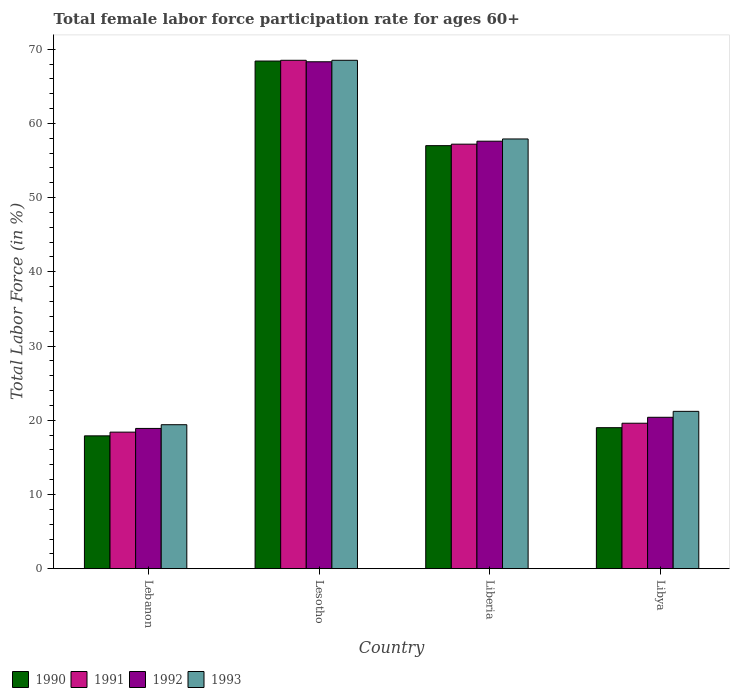How many different coloured bars are there?
Give a very brief answer. 4. How many bars are there on the 3rd tick from the left?
Make the answer very short. 4. How many bars are there on the 3rd tick from the right?
Make the answer very short. 4. What is the label of the 1st group of bars from the left?
Your response must be concise. Lebanon. What is the female labor force participation rate in 1990 in Libya?
Your response must be concise. 19. Across all countries, what is the maximum female labor force participation rate in 1993?
Provide a succinct answer. 68.5. Across all countries, what is the minimum female labor force participation rate in 1991?
Offer a very short reply. 18.4. In which country was the female labor force participation rate in 1990 maximum?
Your answer should be very brief. Lesotho. In which country was the female labor force participation rate in 1990 minimum?
Offer a terse response. Lebanon. What is the total female labor force participation rate in 1992 in the graph?
Provide a short and direct response. 165.2. What is the difference between the female labor force participation rate in 1992 in Lebanon and that in Lesotho?
Your answer should be very brief. -49.4. What is the difference between the female labor force participation rate in 1992 in Libya and the female labor force participation rate in 1993 in Liberia?
Your response must be concise. -37.5. What is the average female labor force participation rate in 1990 per country?
Your response must be concise. 40.58. What is the difference between the female labor force participation rate of/in 1990 and female labor force participation rate of/in 1992 in Libya?
Provide a succinct answer. -1.4. What is the ratio of the female labor force participation rate in 1990 in Lebanon to that in Libya?
Your answer should be very brief. 0.94. Is the difference between the female labor force participation rate in 1990 in Lebanon and Lesotho greater than the difference between the female labor force participation rate in 1992 in Lebanon and Lesotho?
Give a very brief answer. No. What is the difference between the highest and the second highest female labor force participation rate in 1991?
Provide a succinct answer. 37.6. What is the difference between the highest and the lowest female labor force participation rate in 1991?
Your response must be concise. 50.1. Is the sum of the female labor force participation rate in 1990 in Lebanon and Liberia greater than the maximum female labor force participation rate in 1993 across all countries?
Ensure brevity in your answer.  Yes. Is it the case that in every country, the sum of the female labor force participation rate in 1990 and female labor force participation rate in 1992 is greater than the sum of female labor force participation rate in 1991 and female labor force participation rate in 1993?
Provide a short and direct response. No. What does the 2nd bar from the right in Libya represents?
Offer a terse response. 1992. Are all the bars in the graph horizontal?
Ensure brevity in your answer.  No. Where does the legend appear in the graph?
Offer a terse response. Bottom left. What is the title of the graph?
Your answer should be very brief. Total female labor force participation rate for ages 60+. Does "2010" appear as one of the legend labels in the graph?
Your answer should be very brief. No. What is the Total Labor Force (in %) in 1990 in Lebanon?
Give a very brief answer. 17.9. What is the Total Labor Force (in %) of 1991 in Lebanon?
Offer a terse response. 18.4. What is the Total Labor Force (in %) in 1992 in Lebanon?
Your response must be concise. 18.9. What is the Total Labor Force (in %) in 1993 in Lebanon?
Offer a very short reply. 19.4. What is the Total Labor Force (in %) in 1990 in Lesotho?
Keep it short and to the point. 68.4. What is the Total Labor Force (in %) in 1991 in Lesotho?
Your answer should be compact. 68.5. What is the Total Labor Force (in %) in 1992 in Lesotho?
Your answer should be very brief. 68.3. What is the Total Labor Force (in %) of 1993 in Lesotho?
Give a very brief answer. 68.5. What is the Total Labor Force (in %) in 1990 in Liberia?
Provide a short and direct response. 57. What is the Total Labor Force (in %) in 1991 in Liberia?
Keep it short and to the point. 57.2. What is the Total Labor Force (in %) in 1992 in Liberia?
Keep it short and to the point. 57.6. What is the Total Labor Force (in %) of 1993 in Liberia?
Keep it short and to the point. 57.9. What is the Total Labor Force (in %) of 1990 in Libya?
Your response must be concise. 19. What is the Total Labor Force (in %) in 1991 in Libya?
Make the answer very short. 19.6. What is the Total Labor Force (in %) in 1992 in Libya?
Offer a terse response. 20.4. What is the Total Labor Force (in %) of 1993 in Libya?
Your answer should be compact. 21.2. Across all countries, what is the maximum Total Labor Force (in %) in 1990?
Ensure brevity in your answer.  68.4. Across all countries, what is the maximum Total Labor Force (in %) in 1991?
Offer a terse response. 68.5. Across all countries, what is the maximum Total Labor Force (in %) of 1992?
Your response must be concise. 68.3. Across all countries, what is the maximum Total Labor Force (in %) of 1993?
Keep it short and to the point. 68.5. Across all countries, what is the minimum Total Labor Force (in %) of 1990?
Give a very brief answer. 17.9. Across all countries, what is the minimum Total Labor Force (in %) of 1991?
Provide a succinct answer. 18.4. Across all countries, what is the minimum Total Labor Force (in %) of 1992?
Provide a short and direct response. 18.9. Across all countries, what is the minimum Total Labor Force (in %) in 1993?
Ensure brevity in your answer.  19.4. What is the total Total Labor Force (in %) of 1990 in the graph?
Your answer should be very brief. 162.3. What is the total Total Labor Force (in %) of 1991 in the graph?
Your answer should be compact. 163.7. What is the total Total Labor Force (in %) in 1992 in the graph?
Your answer should be compact. 165.2. What is the total Total Labor Force (in %) of 1993 in the graph?
Your answer should be very brief. 167. What is the difference between the Total Labor Force (in %) of 1990 in Lebanon and that in Lesotho?
Give a very brief answer. -50.5. What is the difference between the Total Labor Force (in %) in 1991 in Lebanon and that in Lesotho?
Offer a very short reply. -50.1. What is the difference between the Total Labor Force (in %) in 1992 in Lebanon and that in Lesotho?
Provide a succinct answer. -49.4. What is the difference between the Total Labor Force (in %) in 1993 in Lebanon and that in Lesotho?
Provide a succinct answer. -49.1. What is the difference between the Total Labor Force (in %) in 1990 in Lebanon and that in Liberia?
Your answer should be very brief. -39.1. What is the difference between the Total Labor Force (in %) of 1991 in Lebanon and that in Liberia?
Make the answer very short. -38.8. What is the difference between the Total Labor Force (in %) of 1992 in Lebanon and that in Liberia?
Keep it short and to the point. -38.7. What is the difference between the Total Labor Force (in %) in 1993 in Lebanon and that in Liberia?
Make the answer very short. -38.5. What is the difference between the Total Labor Force (in %) in 1992 in Lebanon and that in Libya?
Provide a succinct answer. -1.5. What is the difference between the Total Labor Force (in %) of 1993 in Lebanon and that in Libya?
Your response must be concise. -1.8. What is the difference between the Total Labor Force (in %) in 1991 in Lesotho and that in Liberia?
Provide a succinct answer. 11.3. What is the difference between the Total Labor Force (in %) in 1992 in Lesotho and that in Liberia?
Keep it short and to the point. 10.7. What is the difference between the Total Labor Force (in %) of 1990 in Lesotho and that in Libya?
Offer a very short reply. 49.4. What is the difference between the Total Labor Force (in %) of 1991 in Lesotho and that in Libya?
Make the answer very short. 48.9. What is the difference between the Total Labor Force (in %) of 1992 in Lesotho and that in Libya?
Your response must be concise. 47.9. What is the difference between the Total Labor Force (in %) in 1993 in Lesotho and that in Libya?
Offer a terse response. 47.3. What is the difference between the Total Labor Force (in %) of 1990 in Liberia and that in Libya?
Your response must be concise. 38. What is the difference between the Total Labor Force (in %) in 1991 in Liberia and that in Libya?
Make the answer very short. 37.6. What is the difference between the Total Labor Force (in %) of 1992 in Liberia and that in Libya?
Ensure brevity in your answer.  37.2. What is the difference between the Total Labor Force (in %) in 1993 in Liberia and that in Libya?
Your answer should be compact. 36.7. What is the difference between the Total Labor Force (in %) of 1990 in Lebanon and the Total Labor Force (in %) of 1991 in Lesotho?
Ensure brevity in your answer.  -50.6. What is the difference between the Total Labor Force (in %) in 1990 in Lebanon and the Total Labor Force (in %) in 1992 in Lesotho?
Your answer should be very brief. -50.4. What is the difference between the Total Labor Force (in %) of 1990 in Lebanon and the Total Labor Force (in %) of 1993 in Lesotho?
Your response must be concise. -50.6. What is the difference between the Total Labor Force (in %) of 1991 in Lebanon and the Total Labor Force (in %) of 1992 in Lesotho?
Keep it short and to the point. -49.9. What is the difference between the Total Labor Force (in %) in 1991 in Lebanon and the Total Labor Force (in %) in 1993 in Lesotho?
Keep it short and to the point. -50.1. What is the difference between the Total Labor Force (in %) in 1992 in Lebanon and the Total Labor Force (in %) in 1993 in Lesotho?
Provide a succinct answer. -49.6. What is the difference between the Total Labor Force (in %) in 1990 in Lebanon and the Total Labor Force (in %) in 1991 in Liberia?
Provide a short and direct response. -39.3. What is the difference between the Total Labor Force (in %) in 1990 in Lebanon and the Total Labor Force (in %) in 1992 in Liberia?
Your response must be concise. -39.7. What is the difference between the Total Labor Force (in %) of 1990 in Lebanon and the Total Labor Force (in %) of 1993 in Liberia?
Offer a very short reply. -40. What is the difference between the Total Labor Force (in %) of 1991 in Lebanon and the Total Labor Force (in %) of 1992 in Liberia?
Provide a succinct answer. -39.2. What is the difference between the Total Labor Force (in %) in 1991 in Lebanon and the Total Labor Force (in %) in 1993 in Liberia?
Your answer should be compact. -39.5. What is the difference between the Total Labor Force (in %) in 1992 in Lebanon and the Total Labor Force (in %) in 1993 in Liberia?
Provide a succinct answer. -39. What is the difference between the Total Labor Force (in %) of 1990 in Lebanon and the Total Labor Force (in %) of 1991 in Libya?
Offer a terse response. -1.7. What is the difference between the Total Labor Force (in %) of 1991 in Lebanon and the Total Labor Force (in %) of 1992 in Libya?
Your answer should be compact. -2. What is the difference between the Total Labor Force (in %) of 1990 in Lesotho and the Total Labor Force (in %) of 1991 in Liberia?
Your answer should be compact. 11.2. What is the difference between the Total Labor Force (in %) of 1990 in Lesotho and the Total Labor Force (in %) of 1991 in Libya?
Give a very brief answer. 48.8. What is the difference between the Total Labor Force (in %) of 1990 in Lesotho and the Total Labor Force (in %) of 1992 in Libya?
Ensure brevity in your answer.  48. What is the difference between the Total Labor Force (in %) in 1990 in Lesotho and the Total Labor Force (in %) in 1993 in Libya?
Ensure brevity in your answer.  47.2. What is the difference between the Total Labor Force (in %) in 1991 in Lesotho and the Total Labor Force (in %) in 1992 in Libya?
Offer a terse response. 48.1. What is the difference between the Total Labor Force (in %) in 1991 in Lesotho and the Total Labor Force (in %) in 1993 in Libya?
Provide a short and direct response. 47.3. What is the difference between the Total Labor Force (in %) of 1992 in Lesotho and the Total Labor Force (in %) of 1993 in Libya?
Provide a succinct answer. 47.1. What is the difference between the Total Labor Force (in %) in 1990 in Liberia and the Total Labor Force (in %) in 1991 in Libya?
Ensure brevity in your answer.  37.4. What is the difference between the Total Labor Force (in %) in 1990 in Liberia and the Total Labor Force (in %) in 1992 in Libya?
Your answer should be very brief. 36.6. What is the difference between the Total Labor Force (in %) in 1990 in Liberia and the Total Labor Force (in %) in 1993 in Libya?
Ensure brevity in your answer.  35.8. What is the difference between the Total Labor Force (in %) of 1991 in Liberia and the Total Labor Force (in %) of 1992 in Libya?
Provide a short and direct response. 36.8. What is the difference between the Total Labor Force (in %) in 1992 in Liberia and the Total Labor Force (in %) in 1993 in Libya?
Ensure brevity in your answer.  36.4. What is the average Total Labor Force (in %) of 1990 per country?
Offer a terse response. 40.58. What is the average Total Labor Force (in %) of 1991 per country?
Keep it short and to the point. 40.92. What is the average Total Labor Force (in %) in 1992 per country?
Offer a very short reply. 41.3. What is the average Total Labor Force (in %) of 1993 per country?
Offer a terse response. 41.75. What is the difference between the Total Labor Force (in %) of 1990 and Total Labor Force (in %) of 1993 in Lebanon?
Provide a short and direct response. -1.5. What is the difference between the Total Labor Force (in %) in 1992 and Total Labor Force (in %) in 1993 in Lesotho?
Offer a very short reply. -0.2. What is the difference between the Total Labor Force (in %) of 1990 and Total Labor Force (in %) of 1993 in Liberia?
Make the answer very short. -0.9. What is the difference between the Total Labor Force (in %) in 1991 and Total Labor Force (in %) in 1992 in Liberia?
Give a very brief answer. -0.4. What is the difference between the Total Labor Force (in %) in 1991 and Total Labor Force (in %) in 1993 in Liberia?
Give a very brief answer. -0.7. What is the difference between the Total Labor Force (in %) of 1992 and Total Labor Force (in %) of 1993 in Liberia?
Provide a succinct answer. -0.3. What is the difference between the Total Labor Force (in %) in 1990 and Total Labor Force (in %) in 1991 in Libya?
Make the answer very short. -0.6. What is the difference between the Total Labor Force (in %) in 1990 and Total Labor Force (in %) in 1993 in Libya?
Offer a very short reply. -2.2. What is the difference between the Total Labor Force (in %) of 1991 and Total Labor Force (in %) of 1992 in Libya?
Offer a terse response. -0.8. What is the difference between the Total Labor Force (in %) of 1991 and Total Labor Force (in %) of 1993 in Libya?
Provide a short and direct response. -1.6. What is the ratio of the Total Labor Force (in %) of 1990 in Lebanon to that in Lesotho?
Keep it short and to the point. 0.26. What is the ratio of the Total Labor Force (in %) in 1991 in Lebanon to that in Lesotho?
Your answer should be compact. 0.27. What is the ratio of the Total Labor Force (in %) of 1992 in Lebanon to that in Lesotho?
Your response must be concise. 0.28. What is the ratio of the Total Labor Force (in %) in 1993 in Lebanon to that in Lesotho?
Your response must be concise. 0.28. What is the ratio of the Total Labor Force (in %) in 1990 in Lebanon to that in Liberia?
Offer a very short reply. 0.31. What is the ratio of the Total Labor Force (in %) in 1991 in Lebanon to that in Liberia?
Provide a succinct answer. 0.32. What is the ratio of the Total Labor Force (in %) of 1992 in Lebanon to that in Liberia?
Keep it short and to the point. 0.33. What is the ratio of the Total Labor Force (in %) in 1993 in Lebanon to that in Liberia?
Offer a terse response. 0.34. What is the ratio of the Total Labor Force (in %) of 1990 in Lebanon to that in Libya?
Offer a terse response. 0.94. What is the ratio of the Total Labor Force (in %) in 1991 in Lebanon to that in Libya?
Keep it short and to the point. 0.94. What is the ratio of the Total Labor Force (in %) of 1992 in Lebanon to that in Libya?
Provide a short and direct response. 0.93. What is the ratio of the Total Labor Force (in %) in 1993 in Lebanon to that in Libya?
Make the answer very short. 0.92. What is the ratio of the Total Labor Force (in %) in 1990 in Lesotho to that in Liberia?
Your response must be concise. 1.2. What is the ratio of the Total Labor Force (in %) in 1991 in Lesotho to that in Liberia?
Offer a terse response. 1.2. What is the ratio of the Total Labor Force (in %) of 1992 in Lesotho to that in Liberia?
Your answer should be very brief. 1.19. What is the ratio of the Total Labor Force (in %) in 1993 in Lesotho to that in Liberia?
Provide a succinct answer. 1.18. What is the ratio of the Total Labor Force (in %) of 1991 in Lesotho to that in Libya?
Your response must be concise. 3.49. What is the ratio of the Total Labor Force (in %) in 1992 in Lesotho to that in Libya?
Provide a succinct answer. 3.35. What is the ratio of the Total Labor Force (in %) of 1993 in Lesotho to that in Libya?
Ensure brevity in your answer.  3.23. What is the ratio of the Total Labor Force (in %) of 1990 in Liberia to that in Libya?
Provide a short and direct response. 3. What is the ratio of the Total Labor Force (in %) of 1991 in Liberia to that in Libya?
Ensure brevity in your answer.  2.92. What is the ratio of the Total Labor Force (in %) in 1992 in Liberia to that in Libya?
Your answer should be very brief. 2.82. What is the ratio of the Total Labor Force (in %) in 1993 in Liberia to that in Libya?
Offer a terse response. 2.73. What is the difference between the highest and the second highest Total Labor Force (in %) in 1990?
Provide a short and direct response. 11.4. What is the difference between the highest and the second highest Total Labor Force (in %) in 1991?
Give a very brief answer. 11.3. What is the difference between the highest and the lowest Total Labor Force (in %) in 1990?
Your response must be concise. 50.5. What is the difference between the highest and the lowest Total Labor Force (in %) of 1991?
Your response must be concise. 50.1. What is the difference between the highest and the lowest Total Labor Force (in %) in 1992?
Offer a terse response. 49.4. What is the difference between the highest and the lowest Total Labor Force (in %) of 1993?
Provide a short and direct response. 49.1. 